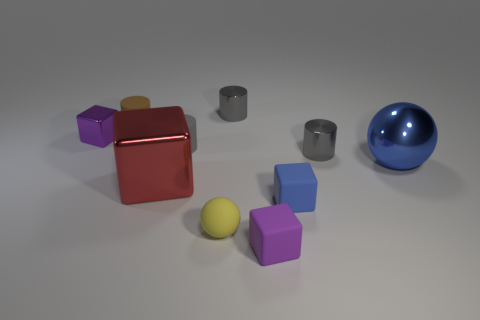The large metallic object that is right of the gray metal cylinder on the left side of the blue object that is in front of the large blue ball is what shape?
Your answer should be very brief. Sphere. The blue metallic object is what size?
Give a very brief answer. Large. There is a gray object that is the same material as the brown cylinder; what is its shape?
Keep it short and to the point. Cylinder. Is the number of large red blocks to the left of the blue metallic sphere less than the number of tiny rubber cubes?
Give a very brief answer. Yes. What color is the ball that is behind the red metal block?
Your answer should be very brief. Blue. Are there any red metal objects of the same shape as the small blue thing?
Offer a very short reply. Yes. How many large red metal things have the same shape as the small yellow thing?
Keep it short and to the point. 0. Is the color of the tiny metallic cube the same as the large block?
Make the answer very short. No. Is the number of small metallic things less than the number of balls?
Give a very brief answer. No. What is the material of the gray cylinder that is right of the tiny blue block?
Keep it short and to the point. Metal. 